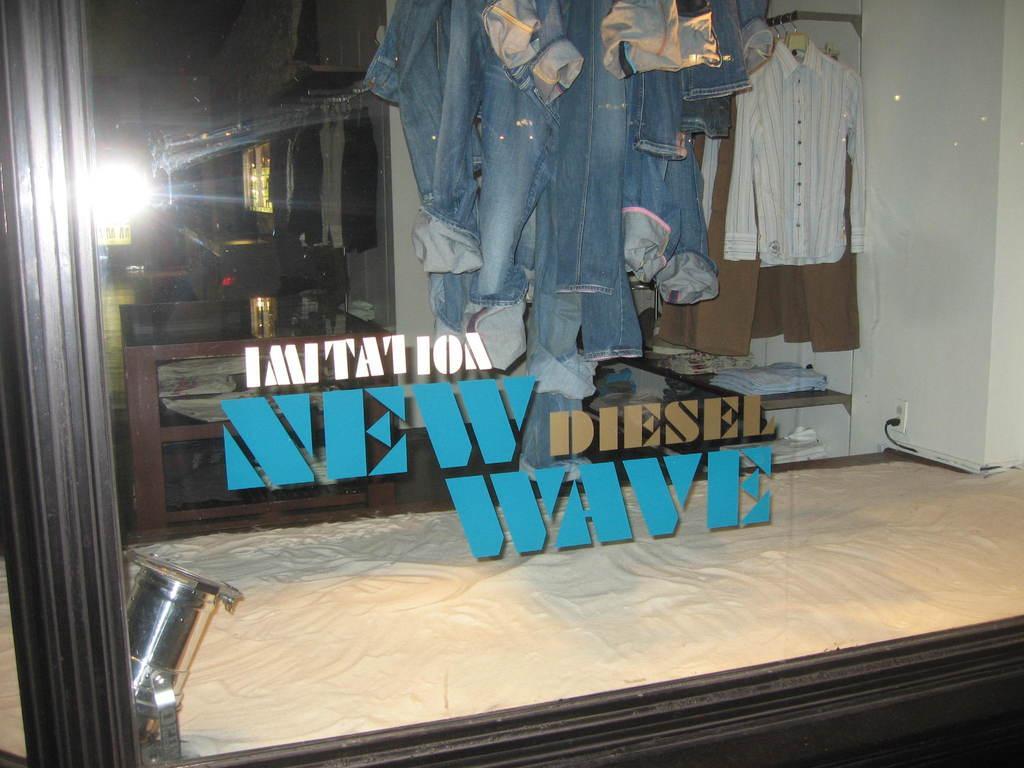Describe this image in one or two sentences. This looks like a glass door. These are the stickers attached to the glass. I can see the clothes hanging. This looks like a bed. Here is a socket with a cable connected to it. This looks like a wall. 